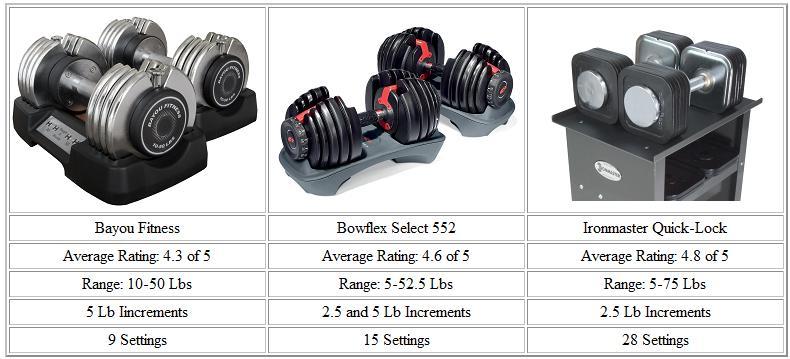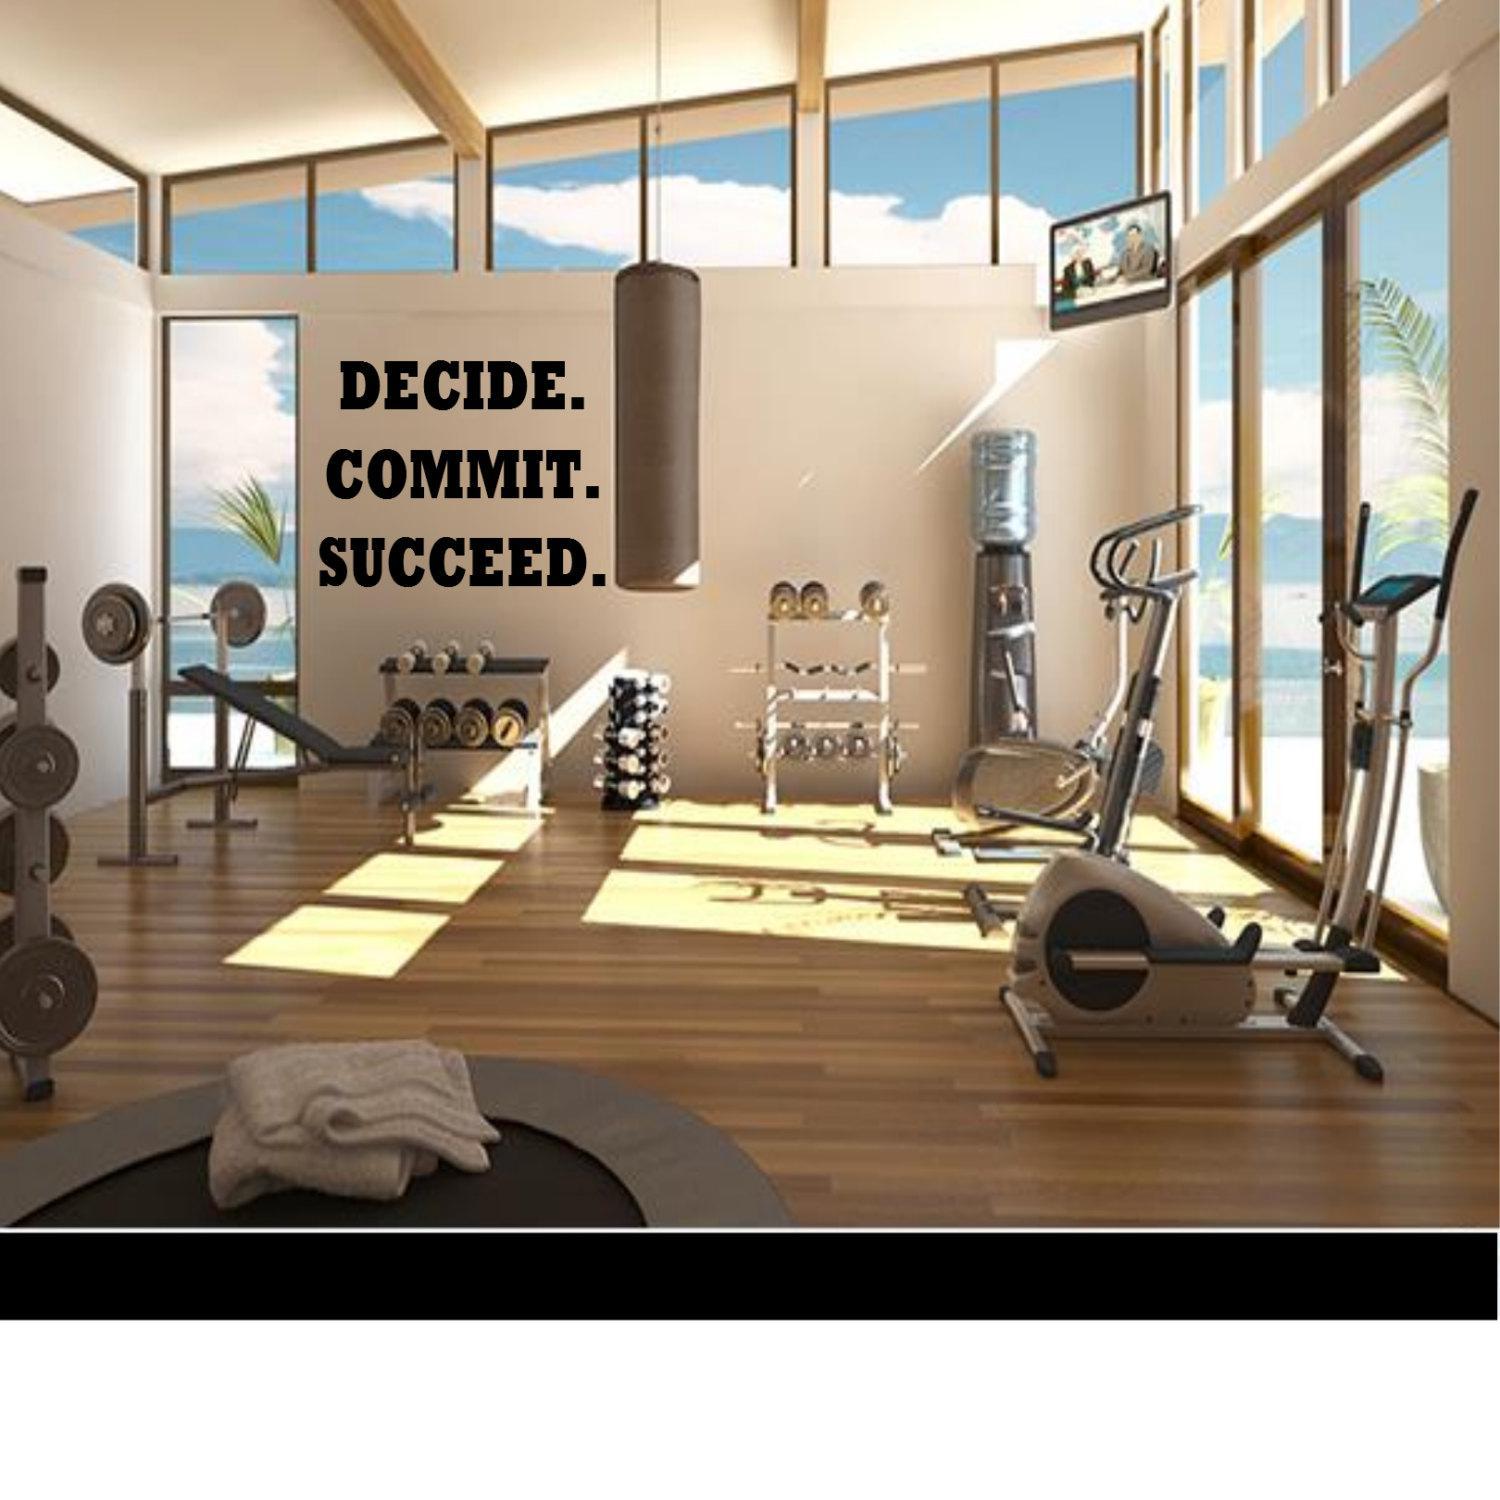The first image is the image on the left, the second image is the image on the right. For the images displayed, is the sentence "The rack in the image on the right holds more than a dozen weights." factually correct? Answer yes or no. No. 